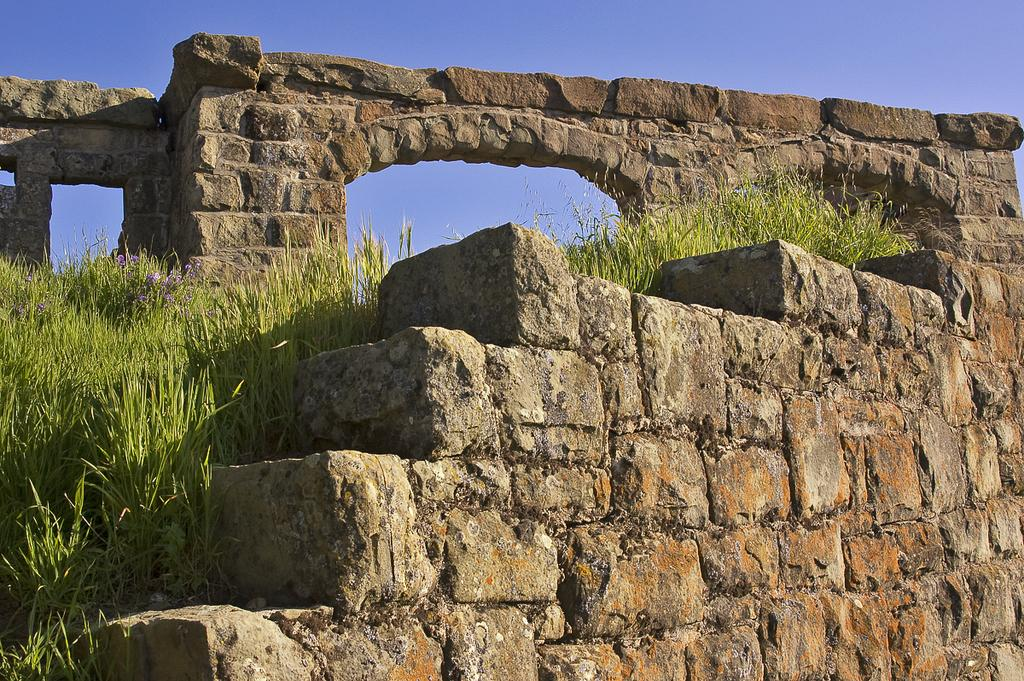What type of structure is located at the front of the image? There is a stone wall in the front of the image. What type of vegetation is on the left side of the image? There is grass on the left side of the image. What is visible at the top of the image? The sky is visible at the top of the image. Can you tell me how many pigs are depicted in the image? There are no pigs present in the image. What unit of measurement is used to describe the size of the stone wall in the image? The provided facts do not mention any specific unit of measurement for the stone wall. 